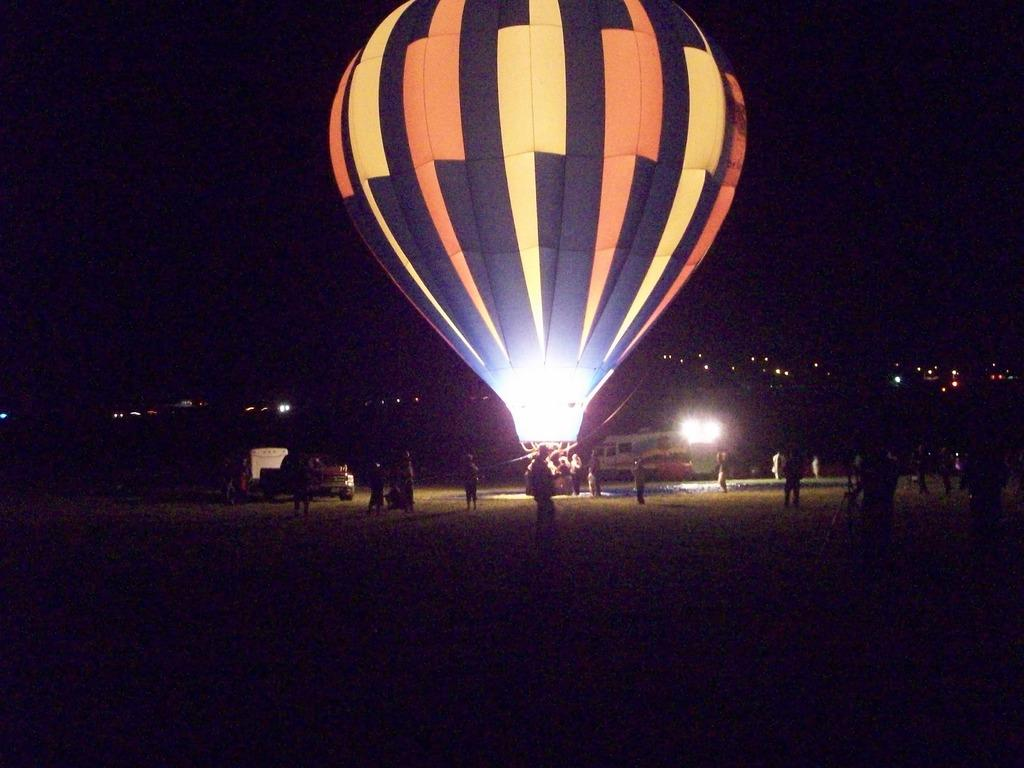What is the overall color scheme of the image? The background of the image is dark. What can be seen illuminating the scene in the image? There are lights visible in the image. What types of objects are present in the image? There are vehicles and a hot air balloon in the image. Are there any living beings in the image? Yes, there are people in the image. What type of harmony is being played by the musicians in the image? There are no musicians or instruments present in the image, so it is not possible to determine if any harmony is being played. 